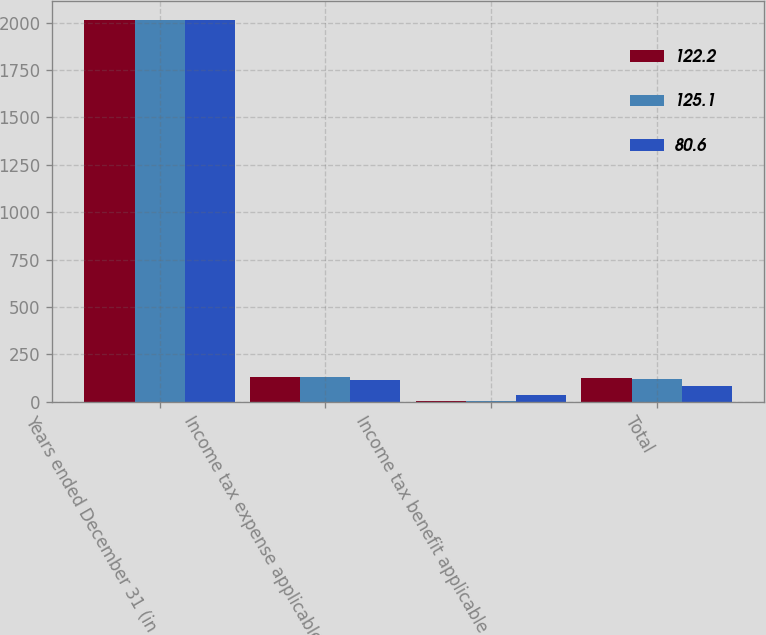<chart> <loc_0><loc_0><loc_500><loc_500><stacked_bar_chart><ecel><fcel>Years ended December 31 (in<fcel>Income tax expense applicable<fcel>Income tax benefit applicable<fcel>Total<nl><fcel>122.2<fcel>2015<fcel>130.4<fcel>5.3<fcel>125.1<nl><fcel>125.1<fcel>2014<fcel>128.9<fcel>6.7<fcel>122.2<nl><fcel>80.6<fcel>2013<fcel>115.2<fcel>34.6<fcel>80.6<nl></chart> 